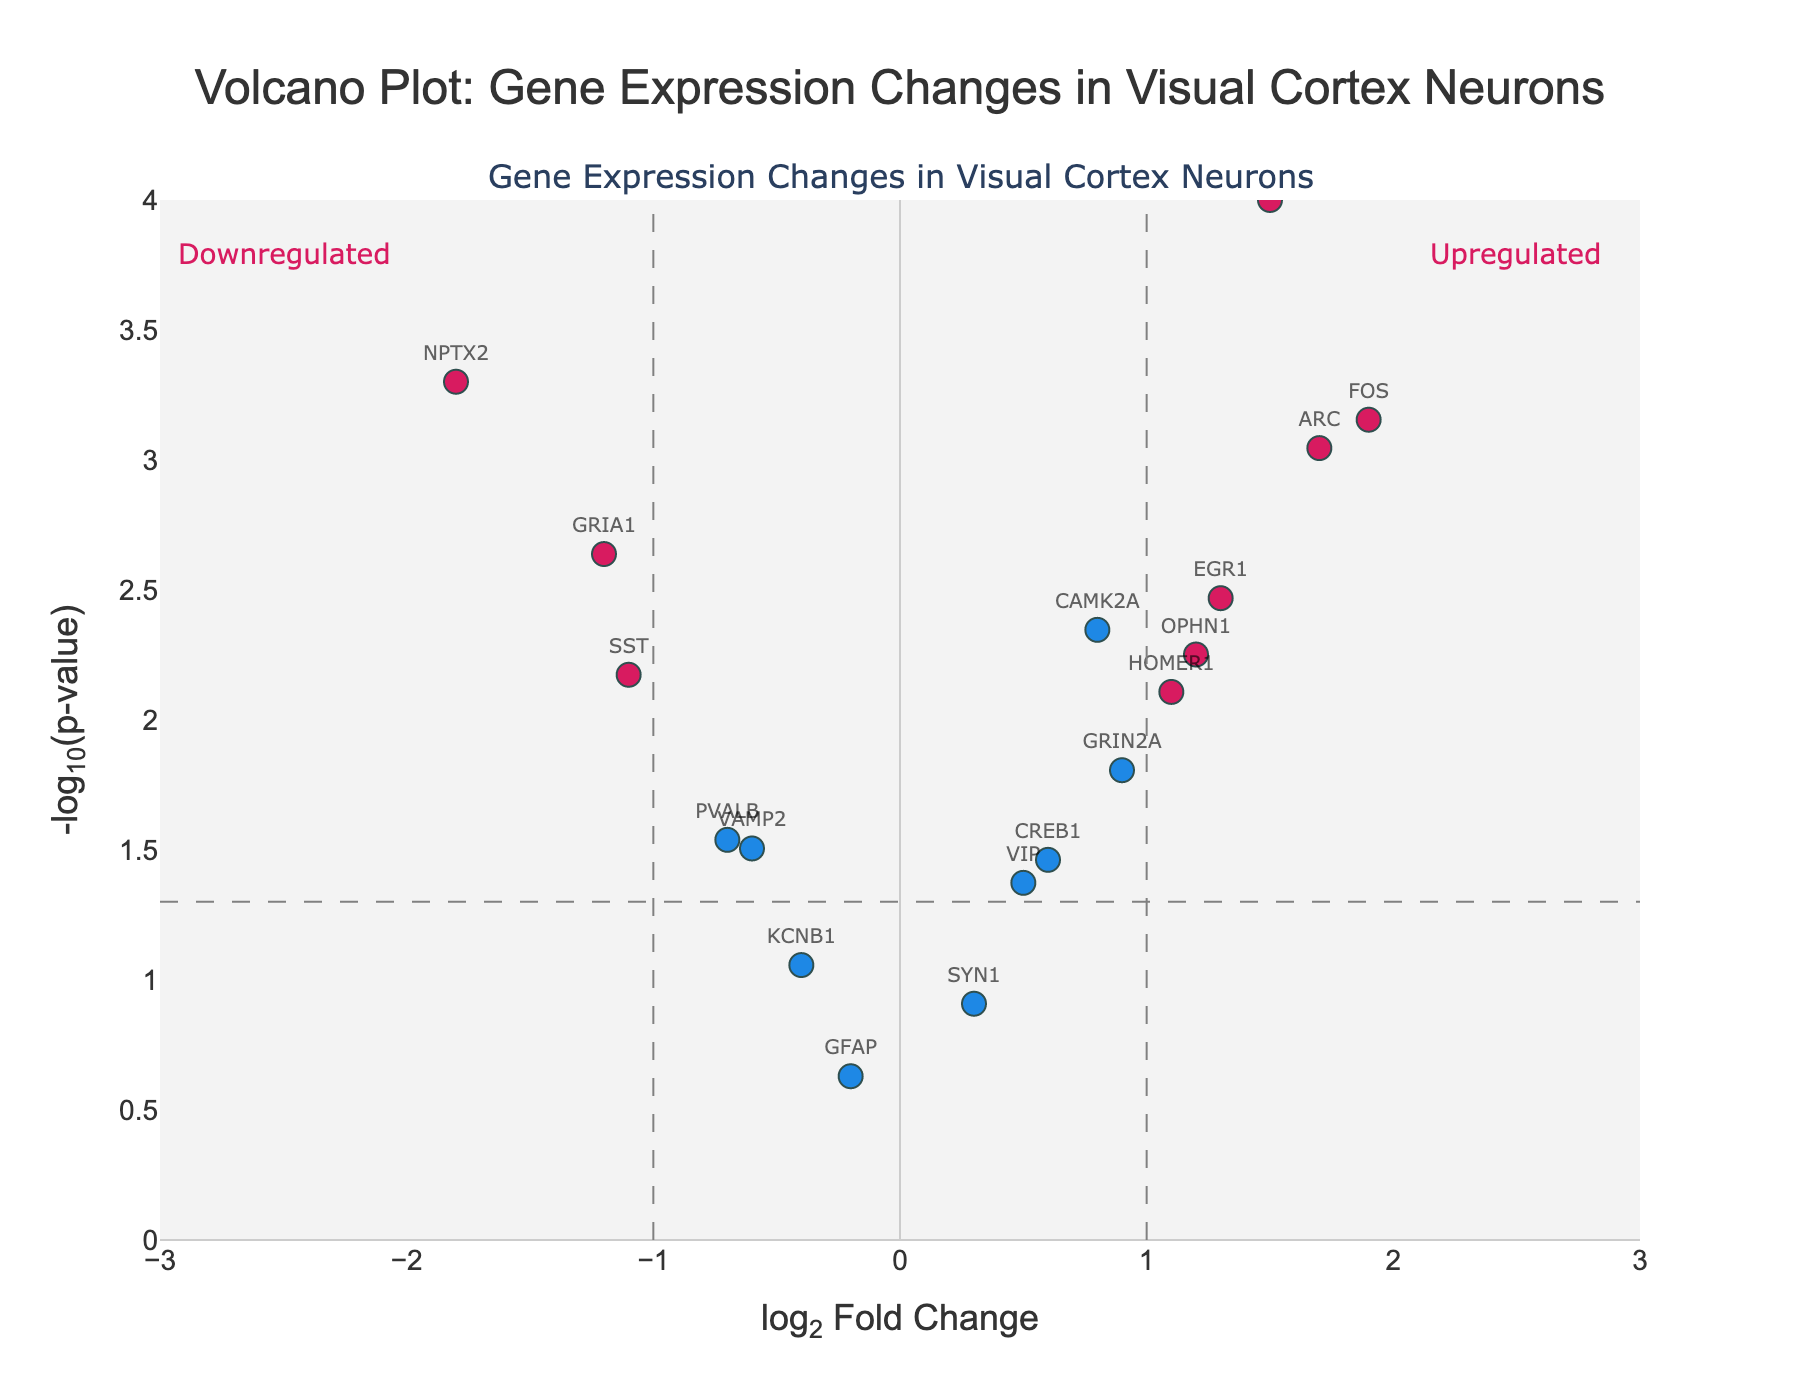Which gene has the highest log2 fold change? By examining the x-axis, identify the data point furthest to the right. According to the plot, the gene with the highest log2 fold change is BDNF, with a value of 2.3.
Answer: BDNF How many genes have a p-value below 0.01? Look at the y-axis and identify points above -log10(0.01), which is 2. The genes above this threshold are GRIA1, CAMK2A, SLC17A7, NPTX2, ARC, NPAS4, FOS, and BDNF. This gives a total of 8 genes.
Answer: 8 Which gene is the most significantly downregulated? Downregulated genes have a negative log2 fold change. Among these, find the one with the highest -log10(p-value). The gene NPTX2 stands out with a -1.8 log2 fold change and a low p-value.
Answer: NPTX2 Which genes have both a log2 fold change greater than 1 and a p-value below 0.05? Check the genes in both x > 1 and above -log10(0.05). The genes are ARC, EGR1, FOS, NPAS4, HOMER1, and SLC17A7.
Answer: ARC, EGR1, FOS, NPAS4, HOMER1, SLC17A7 What is the log2 fold change threshold indicated by the dashed vertical lines? The dashed vertical lines mark the thresholds on the x-axis at approximately log2FoldChange of ±1.
Answer: ±1 Which genes are annotated as upregulated? Upregulated genes have positive log2 fold changes. The ones highlighted in red among these are SLC17A7, ARC, NPAS4, HOMER1, EGR1, FOS, BDNF, OPHN1, and CAMK2A.
Answer: SLC17A7, ARC, NPAS4, HOMER1, EGR1, FOS, BDNF, OPHN1, CAMK2A How does CREB1's p-value compare to the threshold? Find CREB1's position on the y-axis, it is below -log10(0.05). This implies its p-value is above 0.05.
Answer: Above 0.05 What is the -log10(p-value) for NPAS4? Locate NPAS4 on the plot, its y-axis value corresponds to its -log10(p-value), approximately 4.52.
Answer: 4.52 